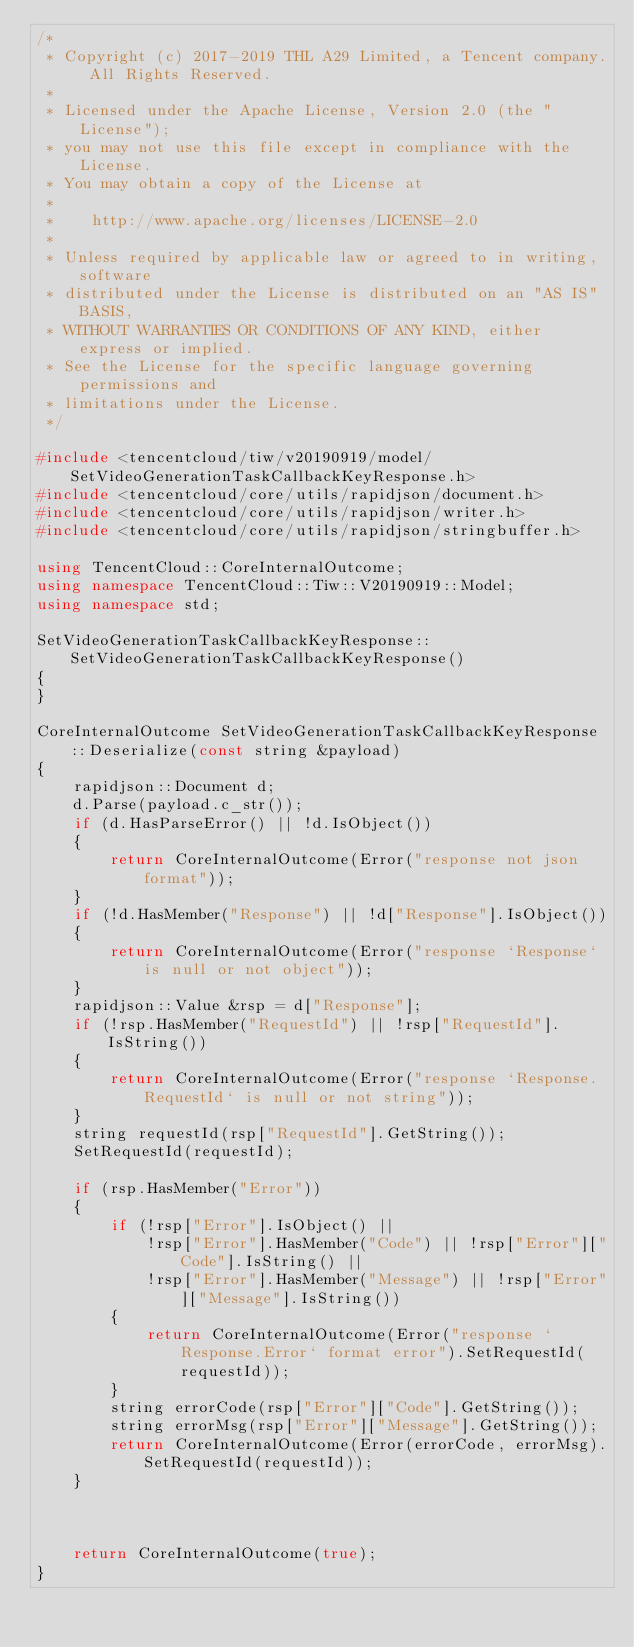<code> <loc_0><loc_0><loc_500><loc_500><_C++_>/*
 * Copyright (c) 2017-2019 THL A29 Limited, a Tencent company. All Rights Reserved.
 *
 * Licensed under the Apache License, Version 2.0 (the "License");
 * you may not use this file except in compliance with the License.
 * You may obtain a copy of the License at
 *
 *    http://www.apache.org/licenses/LICENSE-2.0
 *
 * Unless required by applicable law or agreed to in writing, software
 * distributed under the License is distributed on an "AS IS" BASIS,
 * WITHOUT WARRANTIES OR CONDITIONS OF ANY KIND, either express or implied.
 * See the License for the specific language governing permissions and
 * limitations under the License.
 */

#include <tencentcloud/tiw/v20190919/model/SetVideoGenerationTaskCallbackKeyResponse.h>
#include <tencentcloud/core/utils/rapidjson/document.h>
#include <tencentcloud/core/utils/rapidjson/writer.h>
#include <tencentcloud/core/utils/rapidjson/stringbuffer.h>

using TencentCloud::CoreInternalOutcome;
using namespace TencentCloud::Tiw::V20190919::Model;
using namespace std;

SetVideoGenerationTaskCallbackKeyResponse::SetVideoGenerationTaskCallbackKeyResponse()
{
}

CoreInternalOutcome SetVideoGenerationTaskCallbackKeyResponse::Deserialize(const string &payload)
{
    rapidjson::Document d;
    d.Parse(payload.c_str());
    if (d.HasParseError() || !d.IsObject())
    {
        return CoreInternalOutcome(Error("response not json format"));
    }
    if (!d.HasMember("Response") || !d["Response"].IsObject())
    {
        return CoreInternalOutcome(Error("response `Response` is null or not object"));
    }
    rapidjson::Value &rsp = d["Response"];
    if (!rsp.HasMember("RequestId") || !rsp["RequestId"].IsString())
    {
        return CoreInternalOutcome(Error("response `Response.RequestId` is null or not string"));
    }
    string requestId(rsp["RequestId"].GetString());
    SetRequestId(requestId);

    if (rsp.HasMember("Error"))
    {
        if (!rsp["Error"].IsObject() ||
            !rsp["Error"].HasMember("Code") || !rsp["Error"]["Code"].IsString() ||
            !rsp["Error"].HasMember("Message") || !rsp["Error"]["Message"].IsString())
        {
            return CoreInternalOutcome(Error("response `Response.Error` format error").SetRequestId(requestId));
        }
        string errorCode(rsp["Error"]["Code"].GetString());
        string errorMsg(rsp["Error"]["Message"].GetString());
        return CoreInternalOutcome(Error(errorCode, errorMsg).SetRequestId(requestId));
    }



    return CoreInternalOutcome(true);
}



</code> 